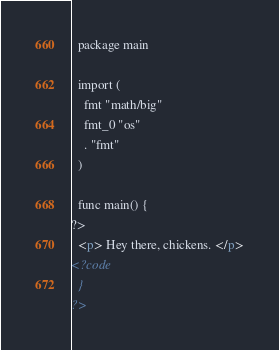<code> <loc_0><loc_0><loc_500><loc_500><_HTML_>  package main

  import (
    fmt "math/big"
    fmt_0 "os"
    . "fmt"
  )

  func main() {
?>
  <p> Hey there, chickens. </p>
<?code
  }
?>
</code> 